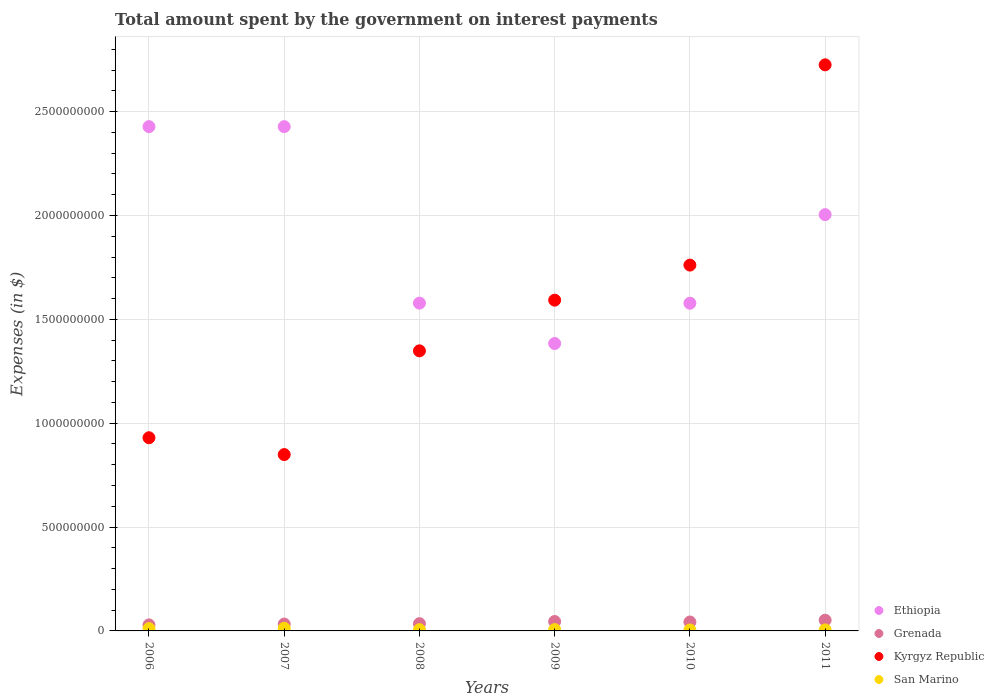How many different coloured dotlines are there?
Provide a short and direct response. 4. Is the number of dotlines equal to the number of legend labels?
Give a very brief answer. Yes. What is the amount spent on interest payments by the government in Grenada in 2006?
Offer a terse response. 2.90e+07. Across all years, what is the maximum amount spent on interest payments by the government in Ethiopia?
Provide a succinct answer. 2.43e+09. Across all years, what is the minimum amount spent on interest payments by the government in Grenada?
Your response must be concise. 2.90e+07. In which year was the amount spent on interest payments by the government in Kyrgyz Republic minimum?
Your answer should be compact. 2007. What is the total amount spent on interest payments by the government in Kyrgyz Republic in the graph?
Provide a short and direct response. 9.21e+09. What is the difference between the amount spent on interest payments by the government in San Marino in 2008 and that in 2009?
Offer a terse response. -4.76e+05. What is the difference between the amount spent on interest payments by the government in Grenada in 2007 and the amount spent on interest payments by the government in San Marino in 2009?
Offer a terse response. 2.66e+07. What is the average amount spent on interest payments by the government in Ethiopia per year?
Provide a short and direct response. 1.90e+09. In the year 2011, what is the difference between the amount spent on interest payments by the government in Kyrgyz Republic and amount spent on interest payments by the government in Ethiopia?
Your answer should be very brief. 7.21e+08. In how many years, is the amount spent on interest payments by the government in San Marino greater than 1500000000 $?
Offer a terse response. 0. What is the ratio of the amount spent on interest payments by the government in Grenada in 2006 to that in 2009?
Offer a very short reply. 0.64. Is the amount spent on interest payments by the government in Ethiopia in 2008 less than that in 2011?
Provide a short and direct response. Yes. Is the difference between the amount spent on interest payments by the government in Kyrgyz Republic in 2006 and 2009 greater than the difference between the amount spent on interest payments by the government in Ethiopia in 2006 and 2009?
Provide a short and direct response. No. What is the difference between the highest and the lowest amount spent on interest payments by the government in Ethiopia?
Your response must be concise. 1.04e+09. Is the sum of the amount spent on interest payments by the government in Ethiopia in 2006 and 2011 greater than the maximum amount spent on interest payments by the government in Grenada across all years?
Your answer should be very brief. Yes. Is it the case that in every year, the sum of the amount spent on interest payments by the government in San Marino and amount spent on interest payments by the government in Ethiopia  is greater than the sum of amount spent on interest payments by the government in Grenada and amount spent on interest payments by the government in Kyrgyz Republic?
Keep it short and to the point. No. Does the amount spent on interest payments by the government in Ethiopia monotonically increase over the years?
Provide a short and direct response. No. Is the amount spent on interest payments by the government in San Marino strictly less than the amount spent on interest payments by the government in Ethiopia over the years?
Your answer should be compact. Yes. How many years are there in the graph?
Your answer should be compact. 6. What is the difference between two consecutive major ticks on the Y-axis?
Provide a succinct answer. 5.00e+08. Where does the legend appear in the graph?
Offer a very short reply. Bottom right. What is the title of the graph?
Offer a terse response. Total amount spent by the government on interest payments. Does "Djibouti" appear as one of the legend labels in the graph?
Offer a terse response. No. What is the label or title of the X-axis?
Give a very brief answer. Years. What is the label or title of the Y-axis?
Your answer should be very brief. Expenses (in $). What is the Expenses (in $) of Ethiopia in 2006?
Give a very brief answer. 2.43e+09. What is the Expenses (in $) of Grenada in 2006?
Your answer should be very brief. 2.90e+07. What is the Expenses (in $) of Kyrgyz Republic in 2006?
Ensure brevity in your answer.  9.30e+08. What is the Expenses (in $) of San Marino in 2006?
Your answer should be very brief. 1.10e+07. What is the Expenses (in $) in Ethiopia in 2007?
Your answer should be very brief. 2.43e+09. What is the Expenses (in $) of Grenada in 2007?
Give a very brief answer. 3.30e+07. What is the Expenses (in $) of Kyrgyz Republic in 2007?
Ensure brevity in your answer.  8.49e+08. What is the Expenses (in $) of San Marino in 2007?
Offer a terse response. 1.27e+07. What is the Expenses (in $) in Ethiopia in 2008?
Make the answer very short. 1.58e+09. What is the Expenses (in $) of Grenada in 2008?
Offer a terse response. 3.49e+07. What is the Expenses (in $) of Kyrgyz Republic in 2008?
Provide a short and direct response. 1.35e+09. What is the Expenses (in $) in San Marino in 2008?
Provide a succinct answer. 5.97e+06. What is the Expenses (in $) of Ethiopia in 2009?
Ensure brevity in your answer.  1.38e+09. What is the Expenses (in $) in Grenada in 2009?
Provide a short and direct response. 4.53e+07. What is the Expenses (in $) of Kyrgyz Republic in 2009?
Offer a very short reply. 1.59e+09. What is the Expenses (in $) of San Marino in 2009?
Provide a short and direct response. 6.45e+06. What is the Expenses (in $) of Ethiopia in 2010?
Provide a short and direct response. 1.58e+09. What is the Expenses (in $) in Grenada in 2010?
Provide a short and direct response. 4.30e+07. What is the Expenses (in $) in Kyrgyz Republic in 2010?
Offer a very short reply. 1.76e+09. What is the Expenses (in $) in San Marino in 2010?
Give a very brief answer. 4.65e+06. What is the Expenses (in $) of Ethiopia in 2011?
Offer a very short reply. 2.00e+09. What is the Expenses (in $) of Grenada in 2011?
Offer a very short reply. 5.16e+07. What is the Expenses (in $) of Kyrgyz Republic in 2011?
Give a very brief answer. 2.73e+09. What is the Expenses (in $) in San Marino in 2011?
Ensure brevity in your answer.  4.89e+06. Across all years, what is the maximum Expenses (in $) of Ethiopia?
Offer a very short reply. 2.43e+09. Across all years, what is the maximum Expenses (in $) in Grenada?
Offer a terse response. 5.16e+07. Across all years, what is the maximum Expenses (in $) in Kyrgyz Republic?
Your answer should be compact. 2.73e+09. Across all years, what is the maximum Expenses (in $) in San Marino?
Keep it short and to the point. 1.27e+07. Across all years, what is the minimum Expenses (in $) in Ethiopia?
Give a very brief answer. 1.38e+09. Across all years, what is the minimum Expenses (in $) of Grenada?
Provide a short and direct response. 2.90e+07. Across all years, what is the minimum Expenses (in $) in Kyrgyz Republic?
Keep it short and to the point. 8.49e+08. Across all years, what is the minimum Expenses (in $) of San Marino?
Give a very brief answer. 4.65e+06. What is the total Expenses (in $) of Ethiopia in the graph?
Ensure brevity in your answer.  1.14e+1. What is the total Expenses (in $) of Grenada in the graph?
Provide a succinct answer. 2.37e+08. What is the total Expenses (in $) in Kyrgyz Republic in the graph?
Keep it short and to the point. 9.21e+09. What is the total Expenses (in $) of San Marino in the graph?
Ensure brevity in your answer.  4.57e+07. What is the difference between the Expenses (in $) in Kyrgyz Republic in 2006 and that in 2007?
Make the answer very short. 8.10e+07. What is the difference between the Expenses (in $) of San Marino in 2006 and that in 2007?
Ensure brevity in your answer.  -1.77e+06. What is the difference between the Expenses (in $) in Ethiopia in 2006 and that in 2008?
Offer a very short reply. 8.50e+08. What is the difference between the Expenses (in $) in Grenada in 2006 and that in 2008?
Keep it short and to the point. -5.90e+06. What is the difference between the Expenses (in $) in Kyrgyz Republic in 2006 and that in 2008?
Make the answer very short. -4.18e+08. What is the difference between the Expenses (in $) in San Marino in 2006 and that in 2008?
Your answer should be very brief. 5.00e+06. What is the difference between the Expenses (in $) of Ethiopia in 2006 and that in 2009?
Make the answer very short. 1.04e+09. What is the difference between the Expenses (in $) in Grenada in 2006 and that in 2009?
Your response must be concise. -1.63e+07. What is the difference between the Expenses (in $) of Kyrgyz Republic in 2006 and that in 2009?
Offer a very short reply. -6.62e+08. What is the difference between the Expenses (in $) of San Marino in 2006 and that in 2009?
Ensure brevity in your answer.  4.52e+06. What is the difference between the Expenses (in $) in Ethiopia in 2006 and that in 2010?
Provide a short and direct response. 8.50e+08. What is the difference between the Expenses (in $) in Grenada in 2006 and that in 2010?
Offer a very short reply. -1.40e+07. What is the difference between the Expenses (in $) in Kyrgyz Republic in 2006 and that in 2010?
Give a very brief answer. -8.31e+08. What is the difference between the Expenses (in $) in San Marino in 2006 and that in 2010?
Make the answer very short. 6.32e+06. What is the difference between the Expenses (in $) in Ethiopia in 2006 and that in 2011?
Make the answer very short. 4.24e+08. What is the difference between the Expenses (in $) in Grenada in 2006 and that in 2011?
Make the answer very short. -2.26e+07. What is the difference between the Expenses (in $) in Kyrgyz Republic in 2006 and that in 2011?
Ensure brevity in your answer.  -1.80e+09. What is the difference between the Expenses (in $) in San Marino in 2006 and that in 2011?
Offer a terse response. 6.08e+06. What is the difference between the Expenses (in $) in Ethiopia in 2007 and that in 2008?
Provide a short and direct response. 8.50e+08. What is the difference between the Expenses (in $) in Grenada in 2007 and that in 2008?
Give a very brief answer. -1.90e+06. What is the difference between the Expenses (in $) of Kyrgyz Republic in 2007 and that in 2008?
Provide a short and direct response. -4.99e+08. What is the difference between the Expenses (in $) of San Marino in 2007 and that in 2008?
Your answer should be very brief. 6.77e+06. What is the difference between the Expenses (in $) in Ethiopia in 2007 and that in 2009?
Ensure brevity in your answer.  1.04e+09. What is the difference between the Expenses (in $) in Grenada in 2007 and that in 2009?
Keep it short and to the point. -1.23e+07. What is the difference between the Expenses (in $) in Kyrgyz Republic in 2007 and that in 2009?
Give a very brief answer. -7.43e+08. What is the difference between the Expenses (in $) in San Marino in 2007 and that in 2009?
Ensure brevity in your answer.  6.29e+06. What is the difference between the Expenses (in $) in Ethiopia in 2007 and that in 2010?
Offer a terse response. 8.50e+08. What is the difference between the Expenses (in $) of Grenada in 2007 and that in 2010?
Provide a succinct answer. -1.00e+07. What is the difference between the Expenses (in $) of Kyrgyz Republic in 2007 and that in 2010?
Keep it short and to the point. -9.12e+08. What is the difference between the Expenses (in $) of San Marino in 2007 and that in 2010?
Offer a very short reply. 8.09e+06. What is the difference between the Expenses (in $) in Ethiopia in 2007 and that in 2011?
Make the answer very short. 4.24e+08. What is the difference between the Expenses (in $) in Grenada in 2007 and that in 2011?
Your answer should be compact. -1.86e+07. What is the difference between the Expenses (in $) of Kyrgyz Republic in 2007 and that in 2011?
Ensure brevity in your answer.  -1.88e+09. What is the difference between the Expenses (in $) in San Marino in 2007 and that in 2011?
Give a very brief answer. 7.85e+06. What is the difference between the Expenses (in $) of Ethiopia in 2008 and that in 2009?
Keep it short and to the point. 1.94e+08. What is the difference between the Expenses (in $) in Grenada in 2008 and that in 2009?
Provide a succinct answer. -1.04e+07. What is the difference between the Expenses (in $) of Kyrgyz Republic in 2008 and that in 2009?
Give a very brief answer. -2.44e+08. What is the difference between the Expenses (in $) of San Marino in 2008 and that in 2009?
Offer a very short reply. -4.76e+05. What is the difference between the Expenses (in $) of Ethiopia in 2008 and that in 2010?
Provide a short and direct response. 4.50e+05. What is the difference between the Expenses (in $) of Grenada in 2008 and that in 2010?
Offer a very short reply. -8.10e+06. What is the difference between the Expenses (in $) of Kyrgyz Republic in 2008 and that in 2010?
Keep it short and to the point. -4.13e+08. What is the difference between the Expenses (in $) in San Marino in 2008 and that in 2010?
Offer a very short reply. 1.32e+06. What is the difference between the Expenses (in $) of Ethiopia in 2008 and that in 2011?
Ensure brevity in your answer.  -4.26e+08. What is the difference between the Expenses (in $) of Grenada in 2008 and that in 2011?
Offer a terse response. -1.67e+07. What is the difference between the Expenses (in $) of Kyrgyz Republic in 2008 and that in 2011?
Ensure brevity in your answer.  -1.38e+09. What is the difference between the Expenses (in $) in San Marino in 2008 and that in 2011?
Your answer should be compact. 1.08e+06. What is the difference between the Expenses (in $) of Ethiopia in 2009 and that in 2010?
Provide a succinct answer. -1.94e+08. What is the difference between the Expenses (in $) of Grenada in 2009 and that in 2010?
Offer a very short reply. 2.30e+06. What is the difference between the Expenses (in $) of Kyrgyz Republic in 2009 and that in 2010?
Your answer should be compact. -1.69e+08. What is the difference between the Expenses (in $) in San Marino in 2009 and that in 2010?
Provide a short and direct response. 1.79e+06. What is the difference between the Expenses (in $) in Ethiopia in 2009 and that in 2011?
Offer a very short reply. -6.20e+08. What is the difference between the Expenses (in $) in Grenada in 2009 and that in 2011?
Keep it short and to the point. -6.30e+06. What is the difference between the Expenses (in $) in Kyrgyz Republic in 2009 and that in 2011?
Keep it short and to the point. -1.13e+09. What is the difference between the Expenses (in $) of San Marino in 2009 and that in 2011?
Your answer should be compact. 1.56e+06. What is the difference between the Expenses (in $) of Ethiopia in 2010 and that in 2011?
Provide a short and direct response. -4.27e+08. What is the difference between the Expenses (in $) of Grenada in 2010 and that in 2011?
Provide a short and direct response. -8.60e+06. What is the difference between the Expenses (in $) in Kyrgyz Republic in 2010 and that in 2011?
Provide a succinct answer. -9.64e+08. What is the difference between the Expenses (in $) in San Marino in 2010 and that in 2011?
Offer a very short reply. -2.39e+05. What is the difference between the Expenses (in $) of Ethiopia in 2006 and the Expenses (in $) of Grenada in 2007?
Offer a terse response. 2.39e+09. What is the difference between the Expenses (in $) in Ethiopia in 2006 and the Expenses (in $) in Kyrgyz Republic in 2007?
Give a very brief answer. 1.58e+09. What is the difference between the Expenses (in $) in Ethiopia in 2006 and the Expenses (in $) in San Marino in 2007?
Make the answer very short. 2.42e+09. What is the difference between the Expenses (in $) in Grenada in 2006 and the Expenses (in $) in Kyrgyz Republic in 2007?
Offer a terse response. -8.20e+08. What is the difference between the Expenses (in $) of Grenada in 2006 and the Expenses (in $) of San Marino in 2007?
Provide a short and direct response. 1.63e+07. What is the difference between the Expenses (in $) in Kyrgyz Republic in 2006 and the Expenses (in $) in San Marino in 2007?
Your response must be concise. 9.17e+08. What is the difference between the Expenses (in $) of Ethiopia in 2006 and the Expenses (in $) of Grenada in 2008?
Offer a very short reply. 2.39e+09. What is the difference between the Expenses (in $) of Ethiopia in 2006 and the Expenses (in $) of Kyrgyz Republic in 2008?
Your answer should be compact. 1.08e+09. What is the difference between the Expenses (in $) in Ethiopia in 2006 and the Expenses (in $) in San Marino in 2008?
Provide a short and direct response. 2.42e+09. What is the difference between the Expenses (in $) of Grenada in 2006 and the Expenses (in $) of Kyrgyz Republic in 2008?
Give a very brief answer. -1.32e+09. What is the difference between the Expenses (in $) of Grenada in 2006 and the Expenses (in $) of San Marino in 2008?
Make the answer very short. 2.30e+07. What is the difference between the Expenses (in $) of Kyrgyz Republic in 2006 and the Expenses (in $) of San Marino in 2008?
Offer a very short reply. 9.24e+08. What is the difference between the Expenses (in $) of Ethiopia in 2006 and the Expenses (in $) of Grenada in 2009?
Ensure brevity in your answer.  2.38e+09. What is the difference between the Expenses (in $) in Ethiopia in 2006 and the Expenses (in $) in Kyrgyz Republic in 2009?
Give a very brief answer. 8.35e+08. What is the difference between the Expenses (in $) of Ethiopia in 2006 and the Expenses (in $) of San Marino in 2009?
Ensure brevity in your answer.  2.42e+09. What is the difference between the Expenses (in $) of Grenada in 2006 and the Expenses (in $) of Kyrgyz Republic in 2009?
Your response must be concise. -1.56e+09. What is the difference between the Expenses (in $) of Grenada in 2006 and the Expenses (in $) of San Marino in 2009?
Keep it short and to the point. 2.26e+07. What is the difference between the Expenses (in $) of Kyrgyz Republic in 2006 and the Expenses (in $) of San Marino in 2009?
Your answer should be compact. 9.24e+08. What is the difference between the Expenses (in $) in Ethiopia in 2006 and the Expenses (in $) in Grenada in 2010?
Make the answer very short. 2.38e+09. What is the difference between the Expenses (in $) in Ethiopia in 2006 and the Expenses (in $) in Kyrgyz Republic in 2010?
Make the answer very short. 6.67e+08. What is the difference between the Expenses (in $) in Ethiopia in 2006 and the Expenses (in $) in San Marino in 2010?
Offer a very short reply. 2.42e+09. What is the difference between the Expenses (in $) of Grenada in 2006 and the Expenses (in $) of Kyrgyz Republic in 2010?
Your answer should be very brief. -1.73e+09. What is the difference between the Expenses (in $) of Grenada in 2006 and the Expenses (in $) of San Marino in 2010?
Your answer should be very brief. 2.43e+07. What is the difference between the Expenses (in $) of Kyrgyz Republic in 2006 and the Expenses (in $) of San Marino in 2010?
Offer a terse response. 9.25e+08. What is the difference between the Expenses (in $) of Ethiopia in 2006 and the Expenses (in $) of Grenada in 2011?
Make the answer very short. 2.38e+09. What is the difference between the Expenses (in $) of Ethiopia in 2006 and the Expenses (in $) of Kyrgyz Republic in 2011?
Your answer should be very brief. -2.98e+08. What is the difference between the Expenses (in $) in Ethiopia in 2006 and the Expenses (in $) in San Marino in 2011?
Provide a short and direct response. 2.42e+09. What is the difference between the Expenses (in $) in Grenada in 2006 and the Expenses (in $) in Kyrgyz Republic in 2011?
Your answer should be compact. -2.70e+09. What is the difference between the Expenses (in $) of Grenada in 2006 and the Expenses (in $) of San Marino in 2011?
Provide a succinct answer. 2.41e+07. What is the difference between the Expenses (in $) in Kyrgyz Republic in 2006 and the Expenses (in $) in San Marino in 2011?
Your answer should be compact. 9.25e+08. What is the difference between the Expenses (in $) in Ethiopia in 2007 and the Expenses (in $) in Grenada in 2008?
Offer a very short reply. 2.39e+09. What is the difference between the Expenses (in $) in Ethiopia in 2007 and the Expenses (in $) in Kyrgyz Republic in 2008?
Provide a short and direct response. 1.08e+09. What is the difference between the Expenses (in $) of Ethiopia in 2007 and the Expenses (in $) of San Marino in 2008?
Provide a succinct answer. 2.42e+09. What is the difference between the Expenses (in $) in Grenada in 2007 and the Expenses (in $) in Kyrgyz Republic in 2008?
Your response must be concise. -1.32e+09. What is the difference between the Expenses (in $) in Grenada in 2007 and the Expenses (in $) in San Marino in 2008?
Your response must be concise. 2.70e+07. What is the difference between the Expenses (in $) of Kyrgyz Republic in 2007 and the Expenses (in $) of San Marino in 2008?
Your answer should be very brief. 8.43e+08. What is the difference between the Expenses (in $) in Ethiopia in 2007 and the Expenses (in $) in Grenada in 2009?
Give a very brief answer. 2.38e+09. What is the difference between the Expenses (in $) in Ethiopia in 2007 and the Expenses (in $) in Kyrgyz Republic in 2009?
Your answer should be very brief. 8.35e+08. What is the difference between the Expenses (in $) in Ethiopia in 2007 and the Expenses (in $) in San Marino in 2009?
Offer a terse response. 2.42e+09. What is the difference between the Expenses (in $) of Grenada in 2007 and the Expenses (in $) of Kyrgyz Republic in 2009?
Offer a very short reply. -1.56e+09. What is the difference between the Expenses (in $) in Grenada in 2007 and the Expenses (in $) in San Marino in 2009?
Provide a short and direct response. 2.66e+07. What is the difference between the Expenses (in $) of Kyrgyz Republic in 2007 and the Expenses (in $) of San Marino in 2009?
Keep it short and to the point. 8.43e+08. What is the difference between the Expenses (in $) in Ethiopia in 2007 and the Expenses (in $) in Grenada in 2010?
Keep it short and to the point. 2.38e+09. What is the difference between the Expenses (in $) in Ethiopia in 2007 and the Expenses (in $) in Kyrgyz Republic in 2010?
Your answer should be compact. 6.67e+08. What is the difference between the Expenses (in $) of Ethiopia in 2007 and the Expenses (in $) of San Marino in 2010?
Ensure brevity in your answer.  2.42e+09. What is the difference between the Expenses (in $) of Grenada in 2007 and the Expenses (in $) of Kyrgyz Republic in 2010?
Provide a succinct answer. -1.73e+09. What is the difference between the Expenses (in $) in Grenada in 2007 and the Expenses (in $) in San Marino in 2010?
Provide a short and direct response. 2.83e+07. What is the difference between the Expenses (in $) in Kyrgyz Republic in 2007 and the Expenses (in $) in San Marino in 2010?
Give a very brief answer. 8.44e+08. What is the difference between the Expenses (in $) in Ethiopia in 2007 and the Expenses (in $) in Grenada in 2011?
Your response must be concise. 2.38e+09. What is the difference between the Expenses (in $) in Ethiopia in 2007 and the Expenses (in $) in Kyrgyz Republic in 2011?
Your response must be concise. -2.98e+08. What is the difference between the Expenses (in $) of Ethiopia in 2007 and the Expenses (in $) of San Marino in 2011?
Give a very brief answer. 2.42e+09. What is the difference between the Expenses (in $) of Grenada in 2007 and the Expenses (in $) of Kyrgyz Republic in 2011?
Provide a short and direct response. -2.69e+09. What is the difference between the Expenses (in $) of Grenada in 2007 and the Expenses (in $) of San Marino in 2011?
Make the answer very short. 2.81e+07. What is the difference between the Expenses (in $) of Kyrgyz Republic in 2007 and the Expenses (in $) of San Marino in 2011?
Your response must be concise. 8.44e+08. What is the difference between the Expenses (in $) of Ethiopia in 2008 and the Expenses (in $) of Grenada in 2009?
Give a very brief answer. 1.53e+09. What is the difference between the Expenses (in $) in Ethiopia in 2008 and the Expenses (in $) in Kyrgyz Republic in 2009?
Give a very brief answer. -1.43e+07. What is the difference between the Expenses (in $) of Ethiopia in 2008 and the Expenses (in $) of San Marino in 2009?
Your response must be concise. 1.57e+09. What is the difference between the Expenses (in $) of Grenada in 2008 and the Expenses (in $) of Kyrgyz Republic in 2009?
Offer a terse response. -1.56e+09. What is the difference between the Expenses (in $) in Grenada in 2008 and the Expenses (in $) in San Marino in 2009?
Ensure brevity in your answer.  2.85e+07. What is the difference between the Expenses (in $) in Kyrgyz Republic in 2008 and the Expenses (in $) in San Marino in 2009?
Your answer should be very brief. 1.34e+09. What is the difference between the Expenses (in $) of Ethiopia in 2008 and the Expenses (in $) of Grenada in 2010?
Provide a short and direct response. 1.54e+09. What is the difference between the Expenses (in $) in Ethiopia in 2008 and the Expenses (in $) in Kyrgyz Republic in 2010?
Offer a very short reply. -1.83e+08. What is the difference between the Expenses (in $) of Ethiopia in 2008 and the Expenses (in $) of San Marino in 2010?
Ensure brevity in your answer.  1.57e+09. What is the difference between the Expenses (in $) in Grenada in 2008 and the Expenses (in $) in Kyrgyz Republic in 2010?
Your answer should be compact. -1.73e+09. What is the difference between the Expenses (in $) of Grenada in 2008 and the Expenses (in $) of San Marino in 2010?
Your response must be concise. 3.02e+07. What is the difference between the Expenses (in $) of Kyrgyz Republic in 2008 and the Expenses (in $) of San Marino in 2010?
Give a very brief answer. 1.34e+09. What is the difference between the Expenses (in $) of Ethiopia in 2008 and the Expenses (in $) of Grenada in 2011?
Your answer should be compact. 1.53e+09. What is the difference between the Expenses (in $) of Ethiopia in 2008 and the Expenses (in $) of Kyrgyz Republic in 2011?
Provide a short and direct response. -1.15e+09. What is the difference between the Expenses (in $) of Ethiopia in 2008 and the Expenses (in $) of San Marino in 2011?
Offer a very short reply. 1.57e+09. What is the difference between the Expenses (in $) of Grenada in 2008 and the Expenses (in $) of Kyrgyz Republic in 2011?
Give a very brief answer. -2.69e+09. What is the difference between the Expenses (in $) of Grenada in 2008 and the Expenses (in $) of San Marino in 2011?
Ensure brevity in your answer.  3.00e+07. What is the difference between the Expenses (in $) in Kyrgyz Republic in 2008 and the Expenses (in $) in San Marino in 2011?
Offer a very short reply. 1.34e+09. What is the difference between the Expenses (in $) of Ethiopia in 2009 and the Expenses (in $) of Grenada in 2010?
Your response must be concise. 1.34e+09. What is the difference between the Expenses (in $) in Ethiopia in 2009 and the Expenses (in $) in Kyrgyz Republic in 2010?
Give a very brief answer. -3.77e+08. What is the difference between the Expenses (in $) in Ethiopia in 2009 and the Expenses (in $) in San Marino in 2010?
Provide a short and direct response. 1.38e+09. What is the difference between the Expenses (in $) of Grenada in 2009 and the Expenses (in $) of Kyrgyz Republic in 2010?
Keep it short and to the point. -1.72e+09. What is the difference between the Expenses (in $) of Grenada in 2009 and the Expenses (in $) of San Marino in 2010?
Your response must be concise. 4.06e+07. What is the difference between the Expenses (in $) in Kyrgyz Republic in 2009 and the Expenses (in $) in San Marino in 2010?
Your answer should be very brief. 1.59e+09. What is the difference between the Expenses (in $) in Ethiopia in 2009 and the Expenses (in $) in Grenada in 2011?
Provide a short and direct response. 1.33e+09. What is the difference between the Expenses (in $) in Ethiopia in 2009 and the Expenses (in $) in Kyrgyz Republic in 2011?
Keep it short and to the point. -1.34e+09. What is the difference between the Expenses (in $) in Ethiopia in 2009 and the Expenses (in $) in San Marino in 2011?
Provide a succinct answer. 1.38e+09. What is the difference between the Expenses (in $) in Grenada in 2009 and the Expenses (in $) in Kyrgyz Republic in 2011?
Ensure brevity in your answer.  -2.68e+09. What is the difference between the Expenses (in $) of Grenada in 2009 and the Expenses (in $) of San Marino in 2011?
Provide a succinct answer. 4.04e+07. What is the difference between the Expenses (in $) in Kyrgyz Republic in 2009 and the Expenses (in $) in San Marino in 2011?
Make the answer very short. 1.59e+09. What is the difference between the Expenses (in $) of Ethiopia in 2010 and the Expenses (in $) of Grenada in 2011?
Ensure brevity in your answer.  1.53e+09. What is the difference between the Expenses (in $) in Ethiopia in 2010 and the Expenses (in $) in Kyrgyz Republic in 2011?
Provide a short and direct response. -1.15e+09. What is the difference between the Expenses (in $) of Ethiopia in 2010 and the Expenses (in $) of San Marino in 2011?
Give a very brief answer. 1.57e+09. What is the difference between the Expenses (in $) of Grenada in 2010 and the Expenses (in $) of Kyrgyz Republic in 2011?
Provide a short and direct response. -2.68e+09. What is the difference between the Expenses (in $) in Grenada in 2010 and the Expenses (in $) in San Marino in 2011?
Provide a succinct answer. 3.81e+07. What is the difference between the Expenses (in $) in Kyrgyz Republic in 2010 and the Expenses (in $) in San Marino in 2011?
Your answer should be very brief. 1.76e+09. What is the average Expenses (in $) of Ethiopia per year?
Your answer should be compact. 1.90e+09. What is the average Expenses (in $) of Grenada per year?
Ensure brevity in your answer.  3.95e+07. What is the average Expenses (in $) in Kyrgyz Republic per year?
Your answer should be compact. 1.53e+09. What is the average Expenses (in $) of San Marino per year?
Offer a terse response. 7.61e+06. In the year 2006, what is the difference between the Expenses (in $) in Ethiopia and Expenses (in $) in Grenada?
Keep it short and to the point. 2.40e+09. In the year 2006, what is the difference between the Expenses (in $) of Ethiopia and Expenses (in $) of Kyrgyz Republic?
Your answer should be very brief. 1.50e+09. In the year 2006, what is the difference between the Expenses (in $) of Ethiopia and Expenses (in $) of San Marino?
Give a very brief answer. 2.42e+09. In the year 2006, what is the difference between the Expenses (in $) of Grenada and Expenses (in $) of Kyrgyz Republic?
Provide a succinct answer. -9.01e+08. In the year 2006, what is the difference between the Expenses (in $) of Grenada and Expenses (in $) of San Marino?
Your answer should be very brief. 1.80e+07. In the year 2006, what is the difference between the Expenses (in $) in Kyrgyz Republic and Expenses (in $) in San Marino?
Your answer should be compact. 9.19e+08. In the year 2007, what is the difference between the Expenses (in $) in Ethiopia and Expenses (in $) in Grenada?
Your answer should be very brief. 2.39e+09. In the year 2007, what is the difference between the Expenses (in $) in Ethiopia and Expenses (in $) in Kyrgyz Republic?
Give a very brief answer. 1.58e+09. In the year 2007, what is the difference between the Expenses (in $) in Ethiopia and Expenses (in $) in San Marino?
Provide a short and direct response. 2.42e+09. In the year 2007, what is the difference between the Expenses (in $) in Grenada and Expenses (in $) in Kyrgyz Republic?
Provide a short and direct response. -8.16e+08. In the year 2007, what is the difference between the Expenses (in $) of Grenada and Expenses (in $) of San Marino?
Ensure brevity in your answer.  2.03e+07. In the year 2007, what is the difference between the Expenses (in $) of Kyrgyz Republic and Expenses (in $) of San Marino?
Your answer should be compact. 8.36e+08. In the year 2008, what is the difference between the Expenses (in $) of Ethiopia and Expenses (in $) of Grenada?
Provide a succinct answer. 1.54e+09. In the year 2008, what is the difference between the Expenses (in $) in Ethiopia and Expenses (in $) in Kyrgyz Republic?
Offer a very short reply. 2.30e+08. In the year 2008, what is the difference between the Expenses (in $) in Ethiopia and Expenses (in $) in San Marino?
Give a very brief answer. 1.57e+09. In the year 2008, what is the difference between the Expenses (in $) in Grenada and Expenses (in $) in Kyrgyz Republic?
Your response must be concise. -1.31e+09. In the year 2008, what is the difference between the Expenses (in $) of Grenada and Expenses (in $) of San Marino?
Keep it short and to the point. 2.89e+07. In the year 2008, what is the difference between the Expenses (in $) of Kyrgyz Republic and Expenses (in $) of San Marino?
Give a very brief answer. 1.34e+09. In the year 2009, what is the difference between the Expenses (in $) in Ethiopia and Expenses (in $) in Grenada?
Your answer should be very brief. 1.34e+09. In the year 2009, what is the difference between the Expenses (in $) of Ethiopia and Expenses (in $) of Kyrgyz Republic?
Offer a very short reply. -2.09e+08. In the year 2009, what is the difference between the Expenses (in $) in Ethiopia and Expenses (in $) in San Marino?
Give a very brief answer. 1.38e+09. In the year 2009, what is the difference between the Expenses (in $) of Grenada and Expenses (in $) of Kyrgyz Republic?
Your response must be concise. -1.55e+09. In the year 2009, what is the difference between the Expenses (in $) of Grenada and Expenses (in $) of San Marino?
Your answer should be compact. 3.89e+07. In the year 2009, what is the difference between the Expenses (in $) of Kyrgyz Republic and Expenses (in $) of San Marino?
Offer a terse response. 1.59e+09. In the year 2010, what is the difference between the Expenses (in $) of Ethiopia and Expenses (in $) of Grenada?
Provide a succinct answer. 1.53e+09. In the year 2010, what is the difference between the Expenses (in $) in Ethiopia and Expenses (in $) in Kyrgyz Republic?
Ensure brevity in your answer.  -1.84e+08. In the year 2010, what is the difference between the Expenses (in $) in Ethiopia and Expenses (in $) in San Marino?
Ensure brevity in your answer.  1.57e+09. In the year 2010, what is the difference between the Expenses (in $) of Grenada and Expenses (in $) of Kyrgyz Republic?
Make the answer very short. -1.72e+09. In the year 2010, what is the difference between the Expenses (in $) of Grenada and Expenses (in $) of San Marino?
Keep it short and to the point. 3.83e+07. In the year 2010, what is the difference between the Expenses (in $) in Kyrgyz Republic and Expenses (in $) in San Marino?
Provide a succinct answer. 1.76e+09. In the year 2011, what is the difference between the Expenses (in $) of Ethiopia and Expenses (in $) of Grenada?
Give a very brief answer. 1.95e+09. In the year 2011, what is the difference between the Expenses (in $) in Ethiopia and Expenses (in $) in Kyrgyz Republic?
Make the answer very short. -7.21e+08. In the year 2011, what is the difference between the Expenses (in $) in Ethiopia and Expenses (in $) in San Marino?
Your response must be concise. 2.00e+09. In the year 2011, what is the difference between the Expenses (in $) in Grenada and Expenses (in $) in Kyrgyz Republic?
Make the answer very short. -2.67e+09. In the year 2011, what is the difference between the Expenses (in $) in Grenada and Expenses (in $) in San Marino?
Give a very brief answer. 4.67e+07. In the year 2011, what is the difference between the Expenses (in $) in Kyrgyz Republic and Expenses (in $) in San Marino?
Your answer should be compact. 2.72e+09. What is the ratio of the Expenses (in $) in Grenada in 2006 to that in 2007?
Make the answer very short. 0.88. What is the ratio of the Expenses (in $) of Kyrgyz Republic in 2006 to that in 2007?
Ensure brevity in your answer.  1.1. What is the ratio of the Expenses (in $) of San Marino in 2006 to that in 2007?
Keep it short and to the point. 0.86. What is the ratio of the Expenses (in $) of Ethiopia in 2006 to that in 2008?
Keep it short and to the point. 1.54. What is the ratio of the Expenses (in $) in Grenada in 2006 to that in 2008?
Make the answer very short. 0.83. What is the ratio of the Expenses (in $) in Kyrgyz Republic in 2006 to that in 2008?
Your answer should be compact. 0.69. What is the ratio of the Expenses (in $) of San Marino in 2006 to that in 2008?
Your answer should be very brief. 1.84. What is the ratio of the Expenses (in $) of Ethiopia in 2006 to that in 2009?
Make the answer very short. 1.75. What is the ratio of the Expenses (in $) of Grenada in 2006 to that in 2009?
Give a very brief answer. 0.64. What is the ratio of the Expenses (in $) in Kyrgyz Republic in 2006 to that in 2009?
Give a very brief answer. 0.58. What is the ratio of the Expenses (in $) of San Marino in 2006 to that in 2009?
Make the answer very short. 1.7. What is the ratio of the Expenses (in $) in Ethiopia in 2006 to that in 2010?
Your answer should be very brief. 1.54. What is the ratio of the Expenses (in $) in Grenada in 2006 to that in 2010?
Ensure brevity in your answer.  0.67. What is the ratio of the Expenses (in $) of Kyrgyz Republic in 2006 to that in 2010?
Keep it short and to the point. 0.53. What is the ratio of the Expenses (in $) of San Marino in 2006 to that in 2010?
Your response must be concise. 2.36. What is the ratio of the Expenses (in $) in Ethiopia in 2006 to that in 2011?
Keep it short and to the point. 1.21. What is the ratio of the Expenses (in $) of Grenada in 2006 to that in 2011?
Provide a succinct answer. 0.56. What is the ratio of the Expenses (in $) of Kyrgyz Republic in 2006 to that in 2011?
Your answer should be very brief. 0.34. What is the ratio of the Expenses (in $) of San Marino in 2006 to that in 2011?
Offer a very short reply. 2.24. What is the ratio of the Expenses (in $) of Ethiopia in 2007 to that in 2008?
Your response must be concise. 1.54. What is the ratio of the Expenses (in $) in Grenada in 2007 to that in 2008?
Your answer should be very brief. 0.95. What is the ratio of the Expenses (in $) of Kyrgyz Republic in 2007 to that in 2008?
Offer a very short reply. 0.63. What is the ratio of the Expenses (in $) in San Marino in 2007 to that in 2008?
Offer a terse response. 2.13. What is the ratio of the Expenses (in $) of Ethiopia in 2007 to that in 2009?
Make the answer very short. 1.75. What is the ratio of the Expenses (in $) in Grenada in 2007 to that in 2009?
Your answer should be very brief. 0.73. What is the ratio of the Expenses (in $) in Kyrgyz Republic in 2007 to that in 2009?
Your answer should be compact. 0.53. What is the ratio of the Expenses (in $) of San Marino in 2007 to that in 2009?
Provide a short and direct response. 1.98. What is the ratio of the Expenses (in $) in Ethiopia in 2007 to that in 2010?
Your answer should be compact. 1.54. What is the ratio of the Expenses (in $) in Grenada in 2007 to that in 2010?
Give a very brief answer. 0.77. What is the ratio of the Expenses (in $) of Kyrgyz Republic in 2007 to that in 2010?
Give a very brief answer. 0.48. What is the ratio of the Expenses (in $) in San Marino in 2007 to that in 2010?
Make the answer very short. 2.74. What is the ratio of the Expenses (in $) in Ethiopia in 2007 to that in 2011?
Make the answer very short. 1.21. What is the ratio of the Expenses (in $) in Grenada in 2007 to that in 2011?
Make the answer very short. 0.64. What is the ratio of the Expenses (in $) of Kyrgyz Republic in 2007 to that in 2011?
Offer a terse response. 0.31. What is the ratio of the Expenses (in $) of San Marino in 2007 to that in 2011?
Give a very brief answer. 2.6. What is the ratio of the Expenses (in $) in Ethiopia in 2008 to that in 2009?
Offer a very short reply. 1.14. What is the ratio of the Expenses (in $) of Grenada in 2008 to that in 2009?
Ensure brevity in your answer.  0.77. What is the ratio of the Expenses (in $) in Kyrgyz Republic in 2008 to that in 2009?
Provide a short and direct response. 0.85. What is the ratio of the Expenses (in $) of San Marino in 2008 to that in 2009?
Give a very brief answer. 0.93. What is the ratio of the Expenses (in $) of Grenada in 2008 to that in 2010?
Your answer should be compact. 0.81. What is the ratio of the Expenses (in $) of Kyrgyz Republic in 2008 to that in 2010?
Provide a short and direct response. 0.77. What is the ratio of the Expenses (in $) in San Marino in 2008 to that in 2010?
Your response must be concise. 1.28. What is the ratio of the Expenses (in $) of Ethiopia in 2008 to that in 2011?
Keep it short and to the point. 0.79. What is the ratio of the Expenses (in $) in Grenada in 2008 to that in 2011?
Offer a very short reply. 0.68. What is the ratio of the Expenses (in $) of Kyrgyz Republic in 2008 to that in 2011?
Offer a terse response. 0.49. What is the ratio of the Expenses (in $) of San Marino in 2008 to that in 2011?
Offer a very short reply. 1.22. What is the ratio of the Expenses (in $) of Ethiopia in 2009 to that in 2010?
Provide a succinct answer. 0.88. What is the ratio of the Expenses (in $) of Grenada in 2009 to that in 2010?
Ensure brevity in your answer.  1.05. What is the ratio of the Expenses (in $) in Kyrgyz Republic in 2009 to that in 2010?
Provide a succinct answer. 0.9. What is the ratio of the Expenses (in $) of San Marino in 2009 to that in 2010?
Provide a succinct answer. 1.39. What is the ratio of the Expenses (in $) in Ethiopia in 2009 to that in 2011?
Make the answer very short. 0.69. What is the ratio of the Expenses (in $) in Grenada in 2009 to that in 2011?
Offer a terse response. 0.88. What is the ratio of the Expenses (in $) of Kyrgyz Republic in 2009 to that in 2011?
Make the answer very short. 0.58. What is the ratio of the Expenses (in $) in San Marino in 2009 to that in 2011?
Your answer should be very brief. 1.32. What is the ratio of the Expenses (in $) of Ethiopia in 2010 to that in 2011?
Your answer should be compact. 0.79. What is the ratio of the Expenses (in $) of Kyrgyz Republic in 2010 to that in 2011?
Keep it short and to the point. 0.65. What is the ratio of the Expenses (in $) of San Marino in 2010 to that in 2011?
Give a very brief answer. 0.95. What is the difference between the highest and the second highest Expenses (in $) of Grenada?
Provide a short and direct response. 6.30e+06. What is the difference between the highest and the second highest Expenses (in $) of Kyrgyz Republic?
Offer a terse response. 9.64e+08. What is the difference between the highest and the second highest Expenses (in $) in San Marino?
Your answer should be very brief. 1.77e+06. What is the difference between the highest and the lowest Expenses (in $) in Ethiopia?
Make the answer very short. 1.04e+09. What is the difference between the highest and the lowest Expenses (in $) in Grenada?
Make the answer very short. 2.26e+07. What is the difference between the highest and the lowest Expenses (in $) in Kyrgyz Republic?
Ensure brevity in your answer.  1.88e+09. What is the difference between the highest and the lowest Expenses (in $) in San Marino?
Provide a succinct answer. 8.09e+06. 